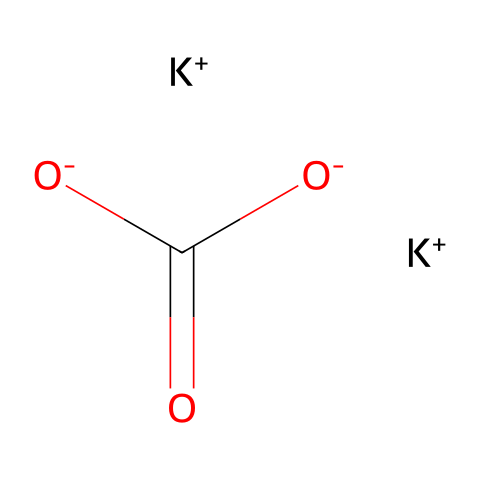What is the total number of potassium atoms in this compound? The provided SMILES notation indicates two potassium ions denoted by [K+]. Each potassium is represented separately in the structure, so we count them.
Answer: 2 How many oxygen atoms are present in this compound? Analyzing the SMILES, we can see the two O atoms from the carbonate group (as seen in C(=O)[O-]). Each carbon is bonded to two oxygens. Therefore, there are two oxygen atoms total.
Answer: 3 What type of compound is potassium carbonate classified as? Considering the presence of potassium ions and carbonate ion, this compound falls under the category of salts, which are the result of acid-base reactions.
Answer: salt What functional group does potassium carbonate contain? The carbonate portion (C(=O)[O-]) indicates the presence of a carbonate ion. This functional group's representations highlight its buffering capacity and relation to acidity.
Answer: carbonate Why is potassium carbonate utilized in glass manufacturing? Potassium carbonate decreases the melting point of silica and improves the chemical durability of glass, allowing for stronger and more stable glass products, which is crucial in medical vials.
Answer: lowers melting point What is the charge of the carbonate ion in this compound? In the given structure, the [O-] indicates that the carbonate ion carries a negative charge, confirming that it is a basic anion participating in ionic bonding.
Answer: -2 How does potassium carbonate interact with water? Potassium carbonate is soluble in water, and when dissolved, it dissociates into potassium ions and carbonate ions, which are important in buffering systems.
Answer: soluble 